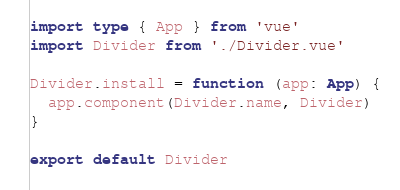<code> <loc_0><loc_0><loc_500><loc_500><_TypeScript_>import type { App } from 'vue'
import Divider from './Divider.vue'

Divider.install = function (app: App) {
  app.component(Divider.name, Divider)
}

export default Divider
</code> 